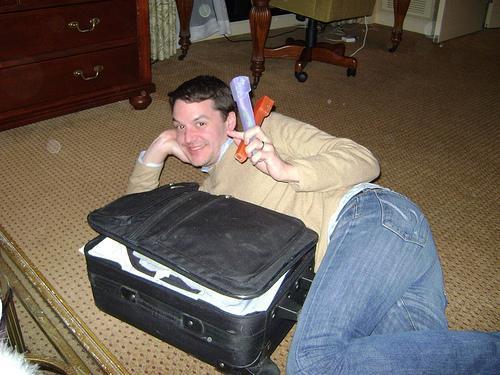How many objects is the person holding?
Give a very brief answer. 2. 